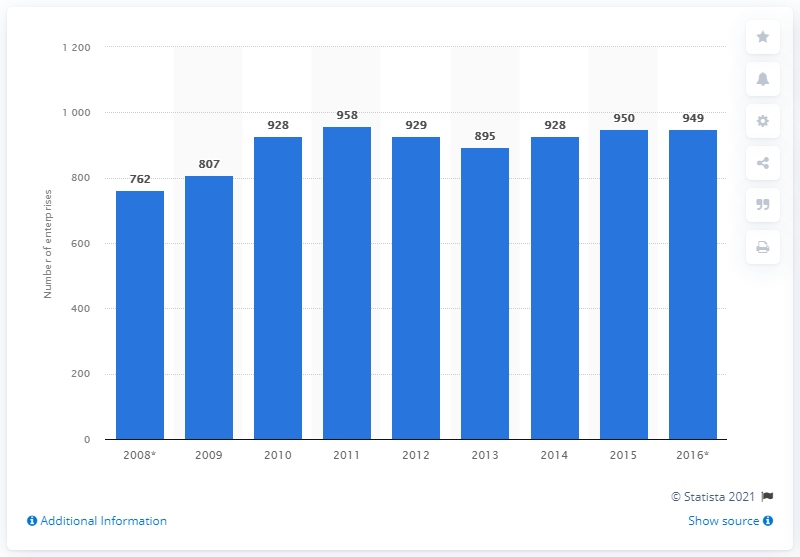Give some essential details in this illustration. In 2015, there were approximately 950 enterprises in the Czech Republic that manufactured paper and paper products. 